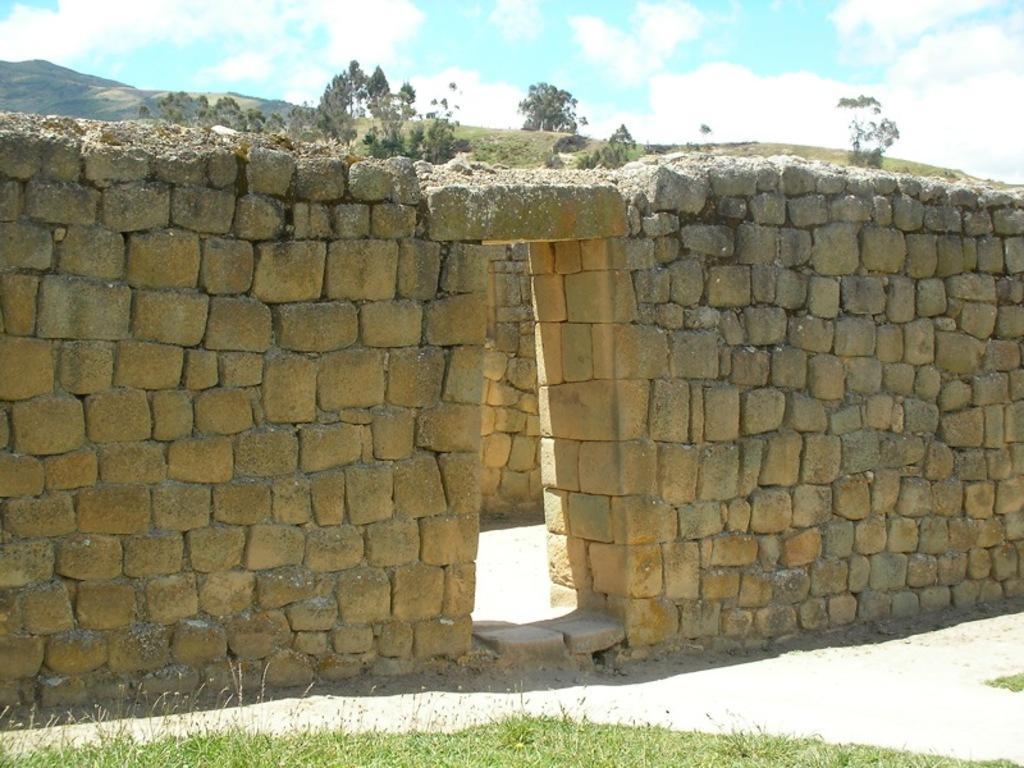Can you describe this image briefly? In this image we can see a wall build with some stones. We can also see grass and some plants. On the backside we can see a wall, a group of trees, the hills and the sky which looks cloudy. 